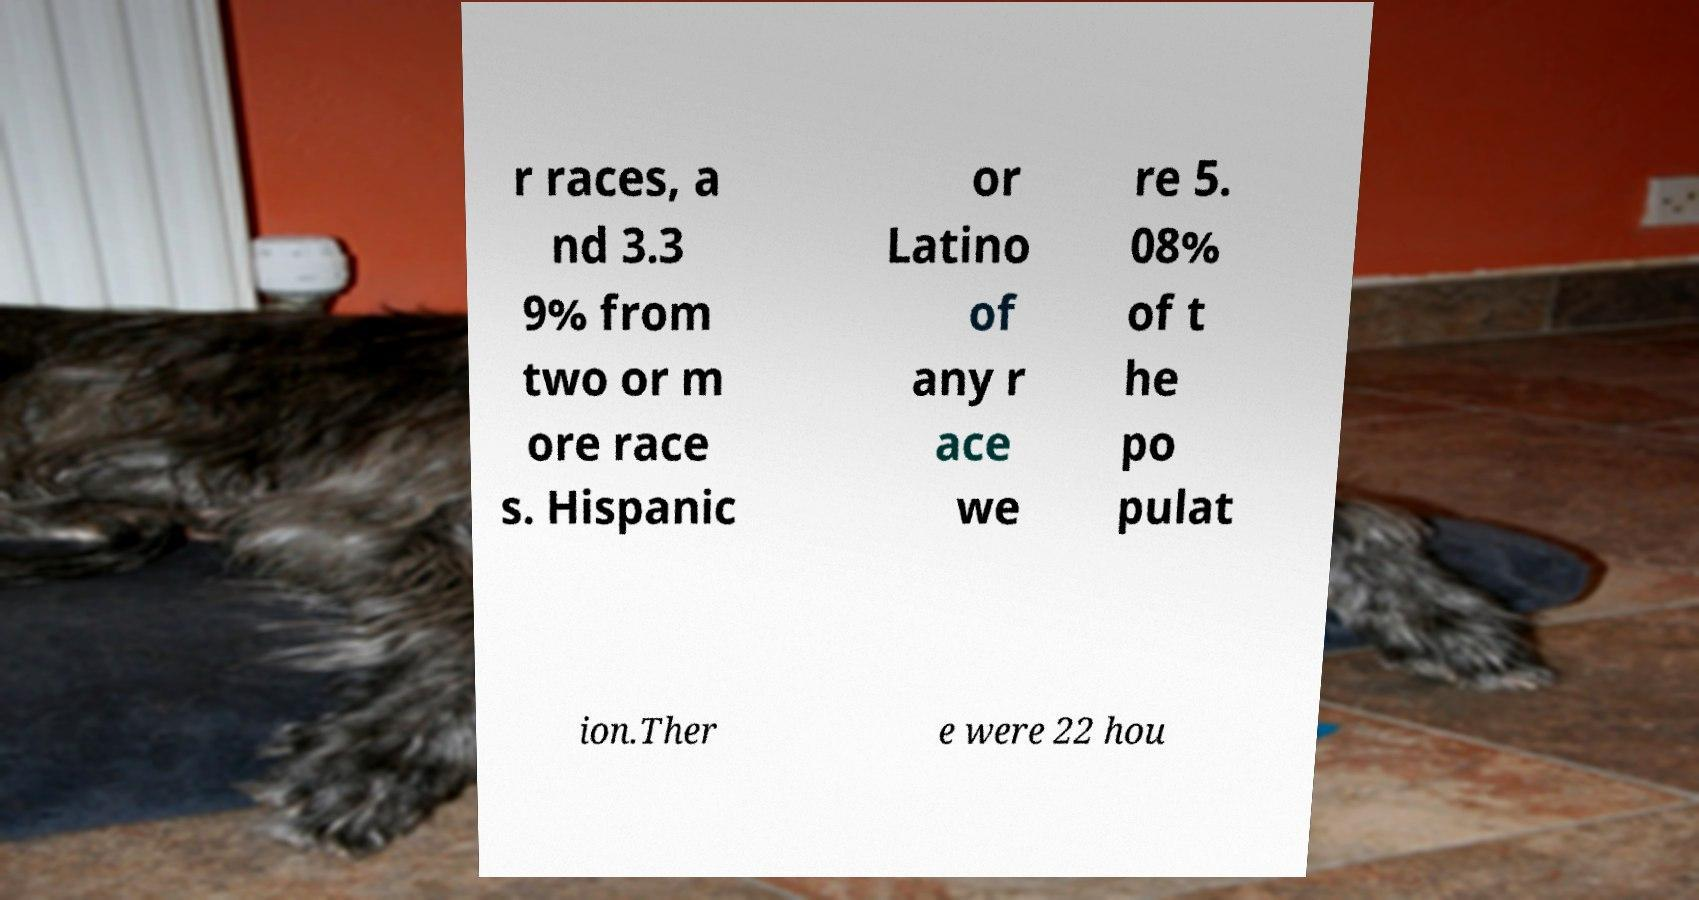There's text embedded in this image that I need extracted. Can you transcribe it verbatim? r races, a nd 3.3 9% from two or m ore race s. Hispanic or Latino of any r ace we re 5. 08% of t he po pulat ion.Ther e were 22 hou 